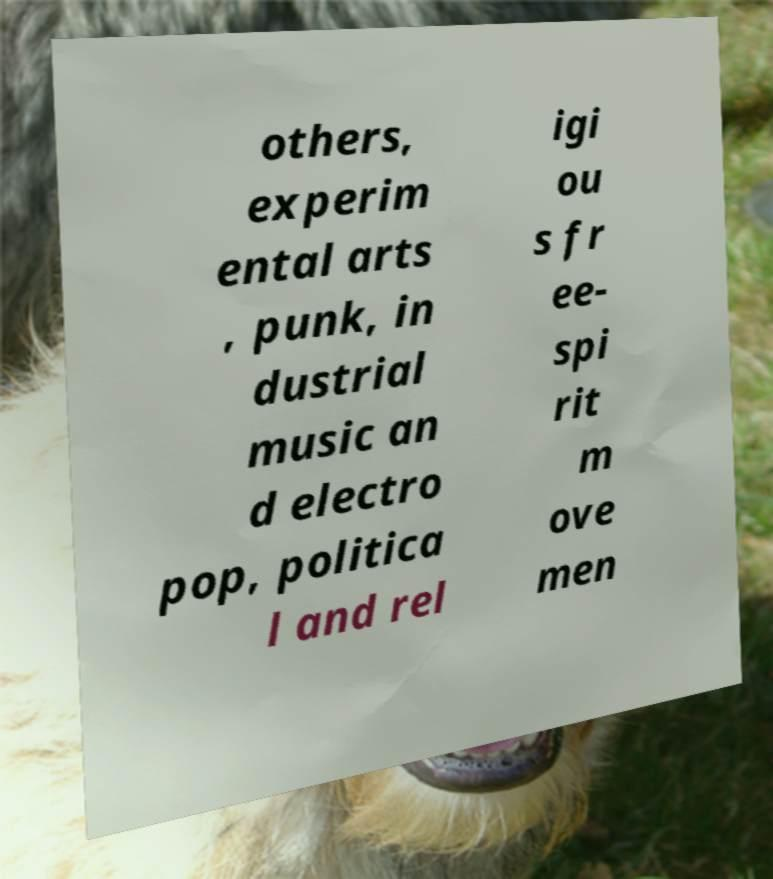Please identify and transcribe the text found in this image. others, experim ental arts , punk, in dustrial music an d electro pop, politica l and rel igi ou s fr ee- spi rit m ove men 